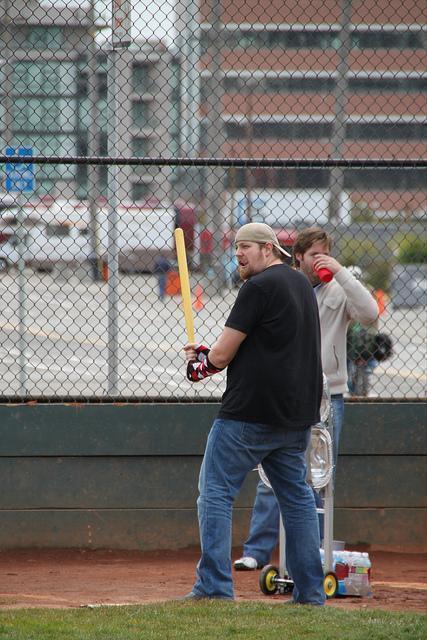What is the man in the black ready to do?
Select the accurate answer and provide justification: `Answer: choice
Rationale: srationale.`
Options: Swing, serve, dunk, sit. Answer: swing.
Rationale: The man wants to swing the bat back and forth. 